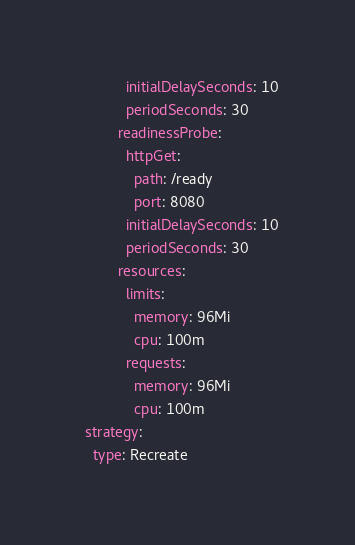Convert code to text. <code><loc_0><loc_0><loc_500><loc_500><_YAML_>            initialDelaySeconds: 10
            periodSeconds: 30
          readinessProbe:
            httpGet:
              path: /ready
              port: 8080
            initialDelaySeconds: 10
            periodSeconds: 30
          resources:
            limits:
              memory: 96Mi
              cpu: 100m
            requests:
              memory: 96Mi
              cpu: 100m
  strategy:
    type: Recreate
</code> 